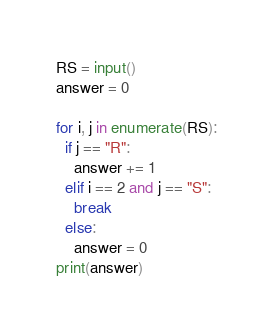Convert code to text. <code><loc_0><loc_0><loc_500><loc_500><_Python_>RS = input()
answer = 0

for i, j in enumerate(RS):
  if j == "R":
    answer += 1
  elif i == 2 and j == "S":
    break
  else:
    answer = 0
print(answer)</code> 